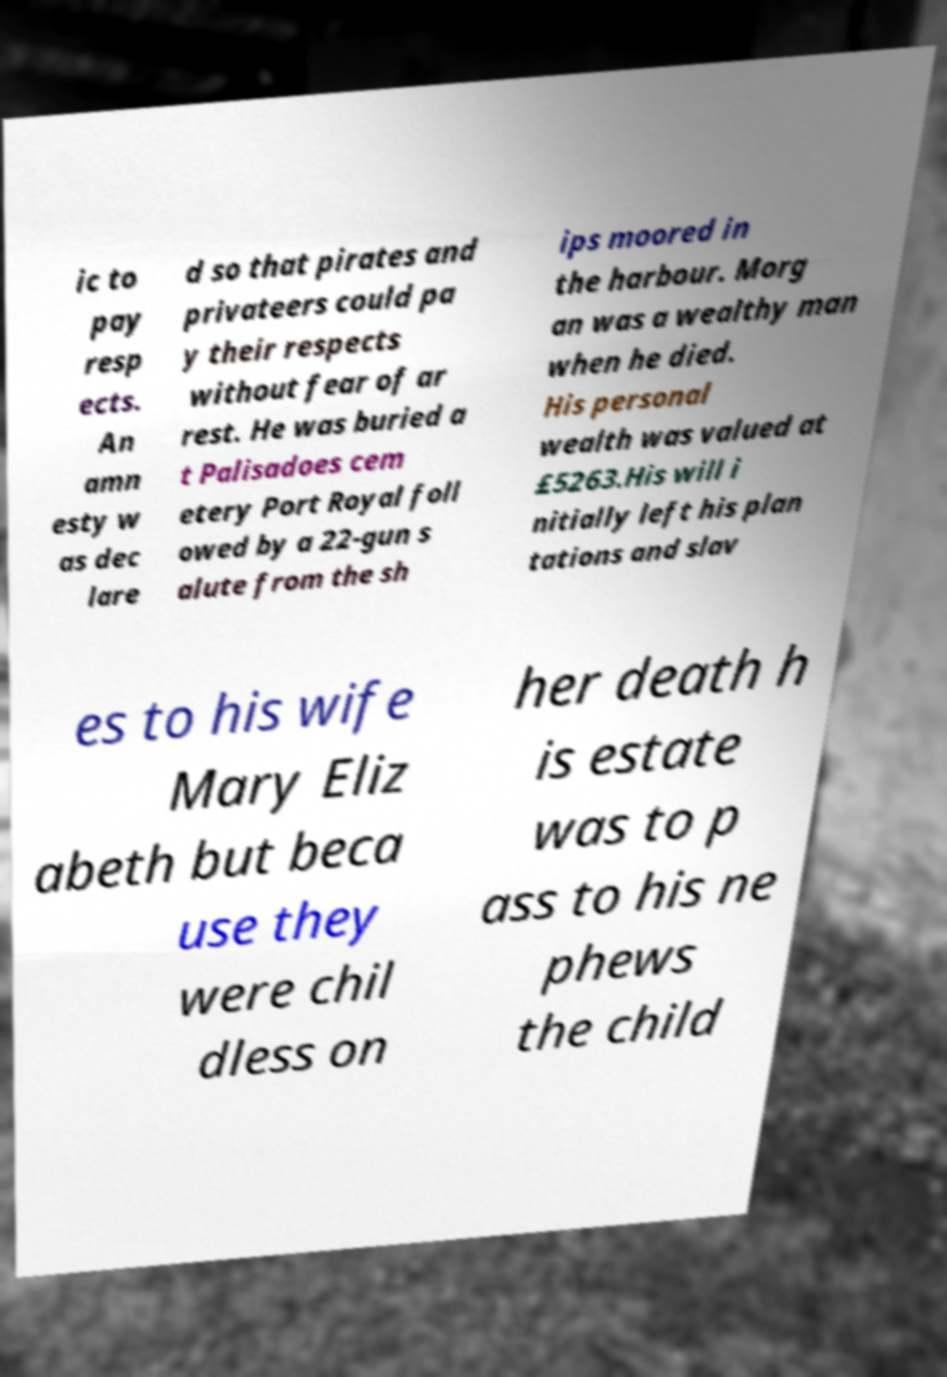I need the written content from this picture converted into text. Can you do that? ic to pay resp ects. An amn esty w as dec lare d so that pirates and privateers could pa y their respects without fear of ar rest. He was buried a t Palisadoes cem etery Port Royal foll owed by a 22-gun s alute from the sh ips moored in the harbour. Morg an was a wealthy man when he died. His personal wealth was valued at £5263.His will i nitially left his plan tations and slav es to his wife Mary Eliz abeth but beca use they were chil dless on her death h is estate was to p ass to his ne phews the child 